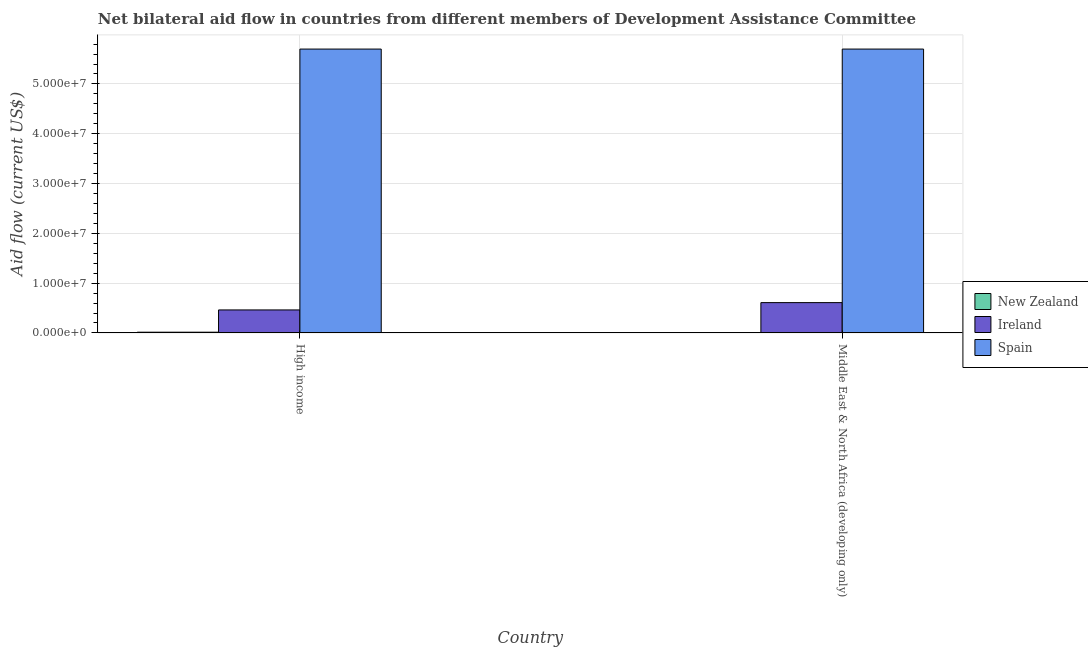How many different coloured bars are there?
Your answer should be very brief. 3. Are the number of bars per tick equal to the number of legend labels?
Give a very brief answer. Yes. What is the label of the 1st group of bars from the left?
Keep it short and to the point. High income. What is the amount of aid provided by spain in Middle East & North Africa (developing only)?
Offer a very short reply. 5.70e+07. Across all countries, what is the maximum amount of aid provided by new zealand?
Keep it short and to the point. 1.50e+05. Across all countries, what is the minimum amount of aid provided by ireland?
Offer a terse response. 4.62e+06. What is the total amount of aid provided by ireland in the graph?
Give a very brief answer. 1.07e+07. What is the difference between the amount of aid provided by spain in High income and that in Middle East & North Africa (developing only)?
Give a very brief answer. 0. What is the difference between the amount of aid provided by spain in Middle East & North Africa (developing only) and the amount of aid provided by new zealand in High income?
Offer a very short reply. 5.68e+07. What is the difference between the amount of aid provided by spain and amount of aid provided by ireland in High income?
Make the answer very short. 5.24e+07. In how many countries, is the amount of aid provided by new zealand greater than the average amount of aid provided by new zealand taken over all countries?
Give a very brief answer. 1. What does the 3rd bar from the left in High income represents?
Provide a short and direct response. Spain. What does the 2nd bar from the right in High income represents?
Offer a very short reply. Ireland. How many bars are there?
Your answer should be compact. 6. Are all the bars in the graph horizontal?
Your answer should be compact. No. How many countries are there in the graph?
Your answer should be compact. 2. What is the difference between two consecutive major ticks on the Y-axis?
Your answer should be very brief. 1.00e+07. Are the values on the major ticks of Y-axis written in scientific E-notation?
Ensure brevity in your answer.  Yes. Does the graph contain any zero values?
Your answer should be very brief. No. Where does the legend appear in the graph?
Ensure brevity in your answer.  Center right. How many legend labels are there?
Your response must be concise. 3. How are the legend labels stacked?
Ensure brevity in your answer.  Vertical. What is the title of the graph?
Your response must be concise. Net bilateral aid flow in countries from different members of Development Assistance Committee. What is the Aid flow (current US$) of Ireland in High income?
Your answer should be compact. 4.62e+06. What is the Aid flow (current US$) in Spain in High income?
Offer a terse response. 5.70e+07. What is the Aid flow (current US$) in Ireland in Middle East & North Africa (developing only)?
Your answer should be compact. 6.09e+06. What is the Aid flow (current US$) in Spain in Middle East & North Africa (developing only)?
Provide a short and direct response. 5.70e+07. Across all countries, what is the maximum Aid flow (current US$) in Ireland?
Offer a very short reply. 6.09e+06. Across all countries, what is the maximum Aid flow (current US$) in Spain?
Your answer should be very brief. 5.70e+07. Across all countries, what is the minimum Aid flow (current US$) in Ireland?
Ensure brevity in your answer.  4.62e+06. Across all countries, what is the minimum Aid flow (current US$) of Spain?
Make the answer very short. 5.70e+07. What is the total Aid flow (current US$) of New Zealand in the graph?
Offer a terse response. 1.60e+05. What is the total Aid flow (current US$) in Ireland in the graph?
Give a very brief answer. 1.07e+07. What is the total Aid flow (current US$) in Spain in the graph?
Make the answer very short. 1.14e+08. What is the difference between the Aid flow (current US$) in New Zealand in High income and that in Middle East & North Africa (developing only)?
Provide a short and direct response. 1.40e+05. What is the difference between the Aid flow (current US$) in Ireland in High income and that in Middle East & North Africa (developing only)?
Offer a terse response. -1.47e+06. What is the difference between the Aid flow (current US$) of Spain in High income and that in Middle East & North Africa (developing only)?
Give a very brief answer. 0. What is the difference between the Aid flow (current US$) in New Zealand in High income and the Aid flow (current US$) in Ireland in Middle East & North Africa (developing only)?
Your response must be concise. -5.94e+06. What is the difference between the Aid flow (current US$) in New Zealand in High income and the Aid flow (current US$) in Spain in Middle East & North Africa (developing only)?
Ensure brevity in your answer.  -5.68e+07. What is the difference between the Aid flow (current US$) in Ireland in High income and the Aid flow (current US$) in Spain in Middle East & North Africa (developing only)?
Ensure brevity in your answer.  -5.24e+07. What is the average Aid flow (current US$) of Ireland per country?
Your response must be concise. 5.36e+06. What is the average Aid flow (current US$) in Spain per country?
Ensure brevity in your answer.  5.70e+07. What is the difference between the Aid flow (current US$) of New Zealand and Aid flow (current US$) of Ireland in High income?
Offer a terse response. -4.47e+06. What is the difference between the Aid flow (current US$) in New Zealand and Aid flow (current US$) in Spain in High income?
Provide a succinct answer. -5.68e+07. What is the difference between the Aid flow (current US$) in Ireland and Aid flow (current US$) in Spain in High income?
Keep it short and to the point. -5.24e+07. What is the difference between the Aid flow (current US$) in New Zealand and Aid flow (current US$) in Ireland in Middle East & North Africa (developing only)?
Give a very brief answer. -6.08e+06. What is the difference between the Aid flow (current US$) of New Zealand and Aid flow (current US$) of Spain in Middle East & North Africa (developing only)?
Give a very brief answer. -5.70e+07. What is the difference between the Aid flow (current US$) in Ireland and Aid flow (current US$) in Spain in Middle East & North Africa (developing only)?
Offer a very short reply. -5.09e+07. What is the ratio of the Aid flow (current US$) of New Zealand in High income to that in Middle East & North Africa (developing only)?
Offer a terse response. 15. What is the ratio of the Aid flow (current US$) of Ireland in High income to that in Middle East & North Africa (developing only)?
Offer a very short reply. 0.76. What is the ratio of the Aid flow (current US$) in Spain in High income to that in Middle East & North Africa (developing only)?
Your response must be concise. 1. What is the difference between the highest and the second highest Aid flow (current US$) in New Zealand?
Make the answer very short. 1.40e+05. What is the difference between the highest and the second highest Aid flow (current US$) in Ireland?
Your answer should be compact. 1.47e+06. What is the difference between the highest and the second highest Aid flow (current US$) of Spain?
Make the answer very short. 0. What is the difference between the highest and the lowest Aid flow (current US$) in Ireland?
Provide a short and direct response. 1.47e+06. What is the difference between the highest and the lowest Aid flow (current US$) in Spain?
Offer a very short reply. 0. 